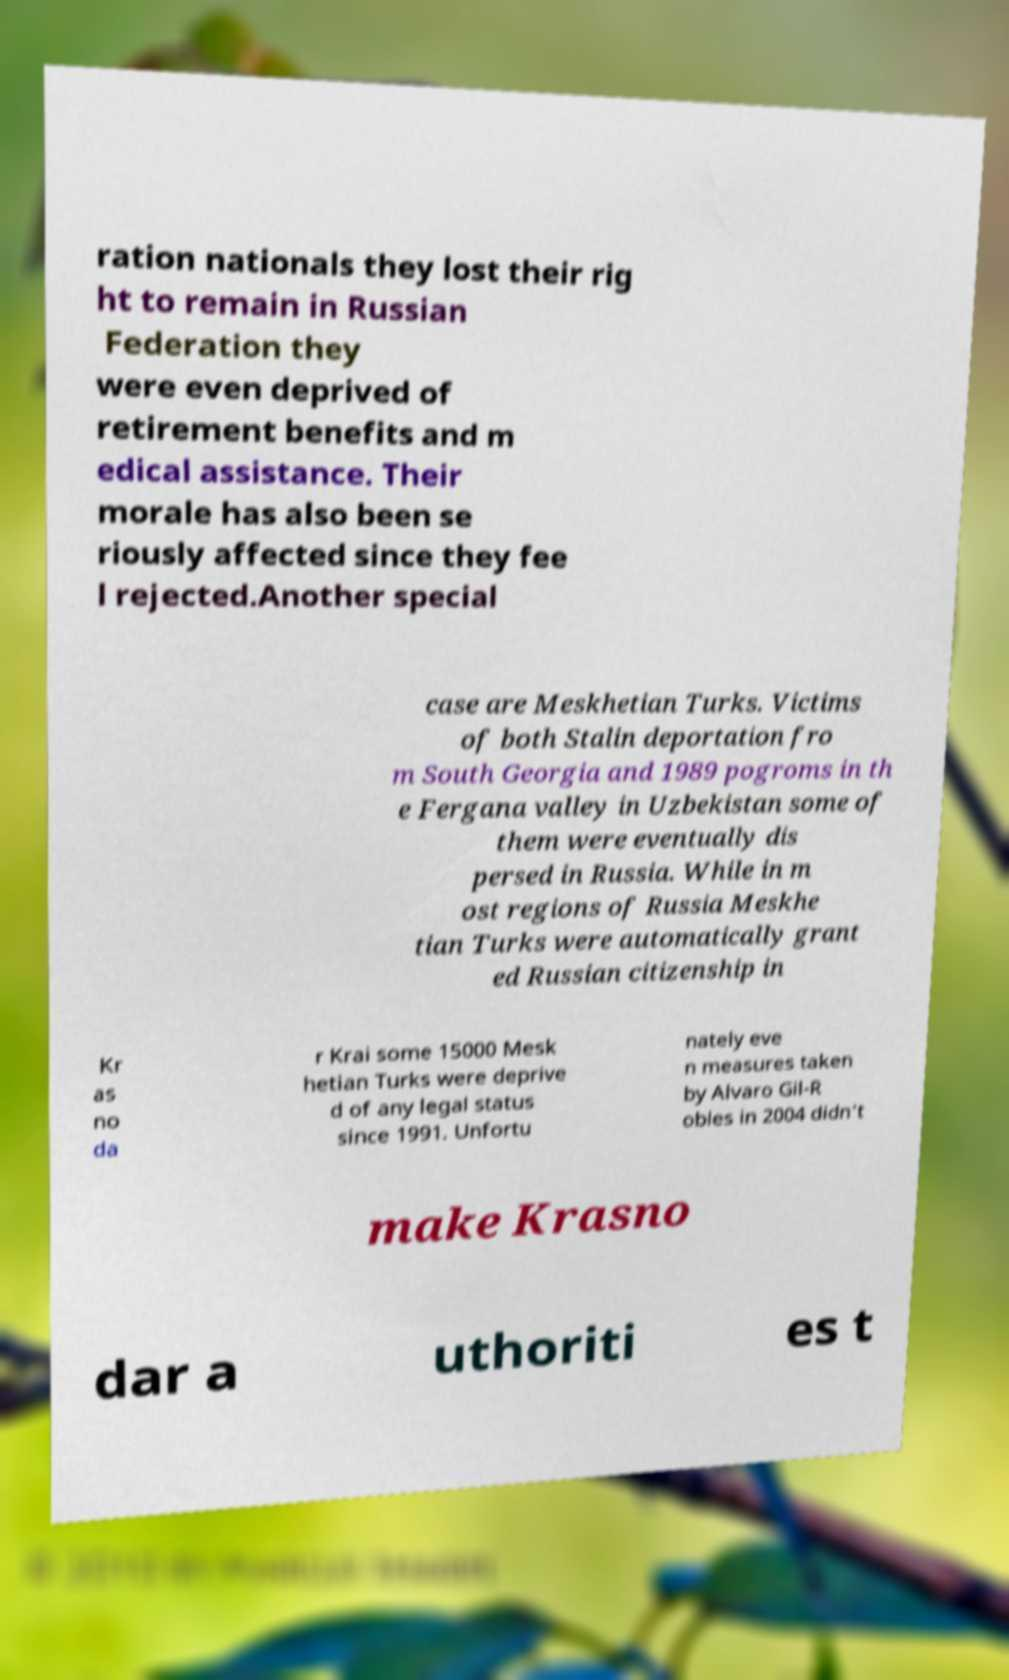I need the written content from this picture converted into text. Can you do that? ration nationals they lost their rig ht to remain in Russian Federation they were even deprived of retirement benefits and m edical assistance. Their morale has also been se riously affected since they fee l rejected.Another special case are Meskhetian Turks. Victims of both Stalin deportation fro m South Georgia and 1989 pogroms in th e Fergana valley in Uzbekistan some of them were eventually dis persed in Russia. While in m ost regions of Russia Meskhe tian Turks were automatically grant ed Russian citizenship in Kr as no da r Krai some 15000 Mesk hetian Turks were deprive d of any legal status since 1991. Unfortu nately eve n measures taken by Alvaro Gil-R obles in 2004 didn't make Krasno dar a uthoriti es t 